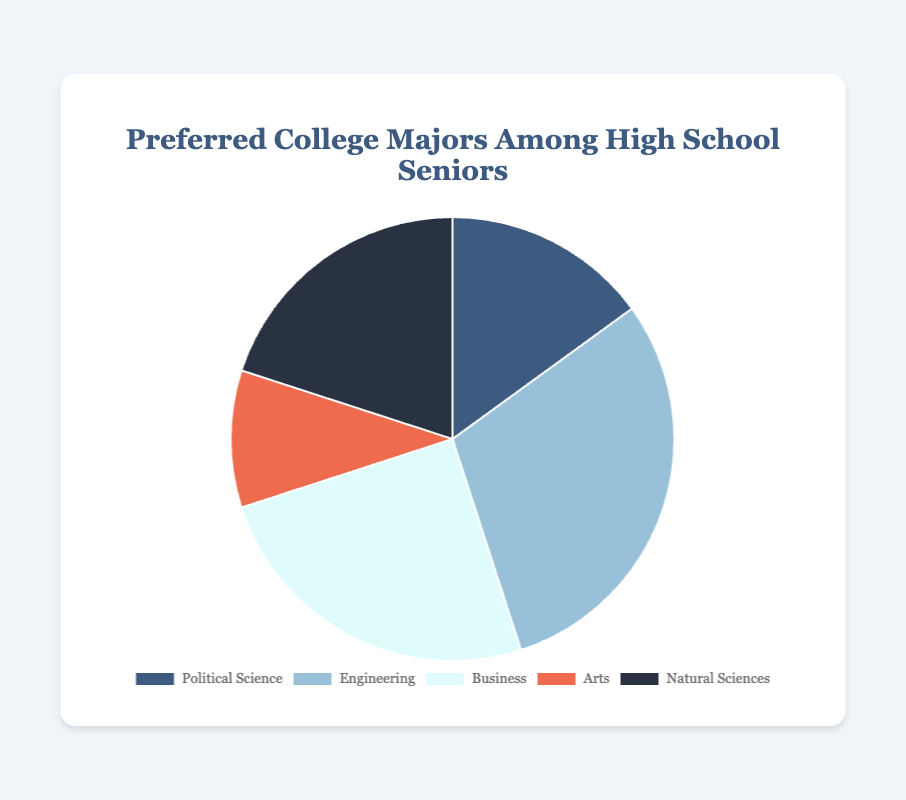What percentage of students prefer Engineering? The pie chart shows the distribution of preferred college majors among high school seniors. The slice labeled "Engineering" indicates the percentage.
Answer: 30% Which major has the least number of students? By observing the chart, the smallest slice corresponds to the major with the least preference. The slice labeled "Arts" is the smallest.
Answer: Arts What is the combined percentage of students preferring Business and Political Science? We need to add the percentages for Business and Political Science. From the chart, Business is 25% and Political Science is 15%. So, 25% + 15% = 40%.
Answer: 40% How much larger is the percentage for Engineering than Arts? Subtract the percentage of Arts from Engineering. Engineering is 30% and Arts is 10%, so 30% - 10% = 20%.
Answer: 20% Which majors have more than 20% of students preferring them? From the pie chart, we look for slices representing more than 20%. Engineering has 30% and Business has 25%. Natural Sciences are exactly 20%, so it is not included.
Answer: Engineering, Business What is the average percentage of students preferring Political Science, Arts, and Natural Sciences? Add the percentages for Political Science, Arts, and Natural Sciences, then divide by 3. (15% + 10% + 20%) / 3 = 45% / 3 = 15%.
Answer: 15% Compare the preferences between Natural Sciences and Business. Which is more popular? Identify the percentages for Natural Sciences and Business. Natural Sciences have 20%, while Business has 25%.
Answer: Business What is the visual characteristic of the slice representing Political Science? Describe the color of the slice. The chart shows the Political Science slice in a specific color.
Answer: Dark blue (or corresponding description as per the chart) Which major slices are adjacent to the slice for Arts? Look at the pie chart to see which slices are next to Arts. Arts is adjacent to Business and Natural Sciences.
Answer: Business, Natural Sciences If you combine the percentages of Engineering and Natural Sciences, what percentage of students prefer these majors together? Add the percentages for Engineering and Natural Sciences. Engineering is 30% and Natural Sciences are 20%, so 30% + 20% = 50%.
Answer: 50% 